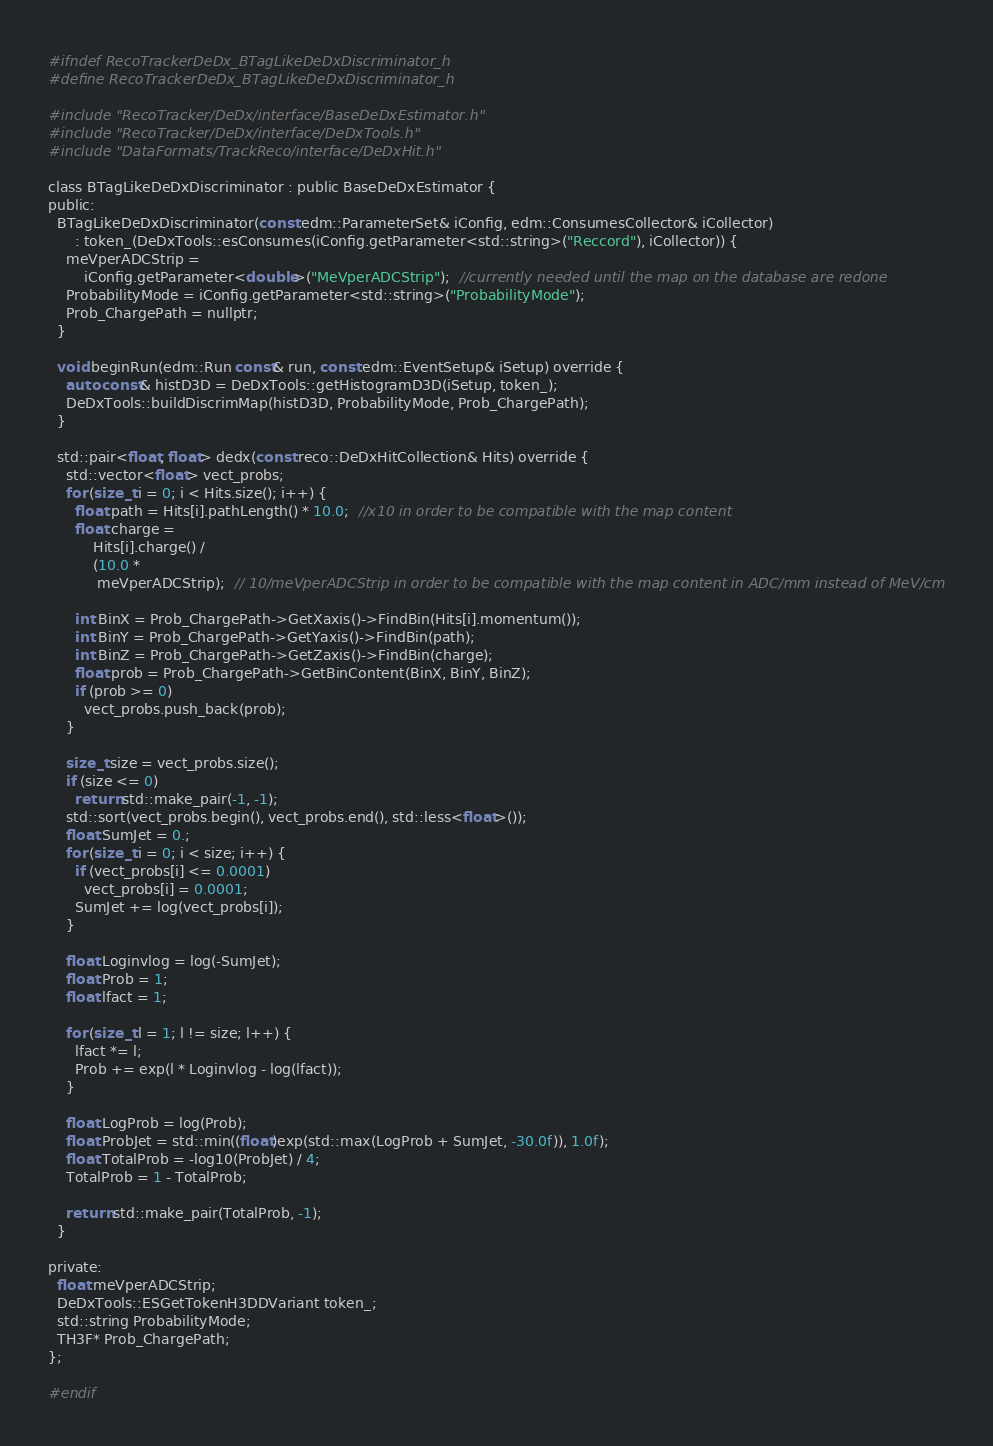<code> <loc_0><loc_0><loc_500><loc_500><_C_>#ifndef RecoTrackerDeDx_BTagLikeDeDxDiscriminator_h
#define RecoTrackerDeDx_BTagLikeDeDxDiscriminator_h

#include "RecoTracker/DeDx/interface/BaseDeDxEstimator.h"
#include "RecoTracker/DeDx/interface/DeDxTools.h"
#include "DataFormats/TrackReco/interface/DeDxHit.h"

class BTagLikeDeDxDiscriminator : public BaseDeDxEstimator {
public:
  BTagLikeDeDxDiscriminator(const edm::ParameterSet& iConfig, edm::ConsumesCollector& iCollector)
      : token_(DeDxTools::esConsumes(iConfig.getParameter<std::string>("Reccord"), iCollector)) {
    meVperADCStrip =
        iConfig.getParameter<double>("MeVperADCStrip");  //currently needed until the map on the database are redone
    ProbabilityMode = iConfig.getParameter<std::string>("ProbabilityMode");
    Prob_ChargePath = nullptr;
  }

  void beginRun(edm::Run const& run, const edm::EventSetup& iSetup) override {
    auto const& histD3D = DeDxTools::getHistogramD3D(iSetup, token_);
    DeDxTools::buildDiscrimMap(histD3D, ProbabilityMode, Prob_ChargePath);
  }

  std::pair<float, float> dedx(const reco::DeDxHitCollection& Hits) override {
    std::vector<float> vect_probs;
    for (size_t i = 0; i < Hits.size(); i++) {
      float path = Hits[i].pathLength() * 10.0;  //x10 in order to be compatible with the map content
      float charge =
          Hits[i].charge() /
          (10.0 *
           meVperADCStrip);  // 10/meVperADCStrip in order to be compatible with the map content in ADC/mm instead of MeV/cm

      int BinX = Prob_ChargePath->GetXaxis()->FindBin(Hits[i].momentum());
      int BinY = Prob_ChargePath->GetYaxis()->FindBin(path);
      int BinZ = Prob_ChargePath->GetZaxis()->FindBin(charge);
      float prob = Prob_ChargePath->GetBinContent(BinX, BinY, BinZ);
      if (prob >= 0)
        vect_probs.push_back(prob);
    }

    size_t size = vect_probs.size();
    if (size <= 0)
      return std::make_pair(-1, -1);
    std::sort(vect_probs.begin(), vect_probs.end(), std::less<float>());
    float SumJet = 0.;
    for (size_t i = 0; i < size; i++) {
      if (vect_probs[i] <= 0.0001)
        vect_probs[i] = 0.0001;
      SumJet += log(vect_probs[i]);
    }

    float Loginvlog = log(-SumJet);
    float Prob = 1;
    float lfact = 1;

    for (size_t l = 1; l != size; l++) {
      lfact *= l;
      Prob += exp(l * Loginvlog - log(lfact));
    }

    float LogProb = log(Prob);
    float ProbJet = std::min((float)exp(std::max(LogProb + SumJet, -30.0f)), 1.0f);
    float TotalProb = -log10(ProbJet) / 4;
    TotalProb = 1 - TotalProb;

    return std::make_pair(TotalProb, -1);
  }

private:
  float meVperADCStrip;
  DeDxTools::ESGetTokenH3DDVariant token_;
  std::string ProbabilityMode;
  TH3F* Prob_ChargePath;
};

#endif
</code> 